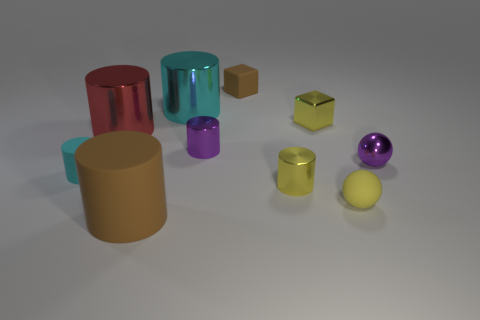What is the material of the thing that is the same color as the small rubber cube?
Keep it short and to the point. Rubber. How many other things are the same material as the yellow cylinder?
Offer a terse response. 5. What is the shape of the cyan thing that is behind the matte cylinder to the left of the large red thing?
Give a very brief answer. Cylinder. What size is the cylinder in front of the yellow sphere?
Give a very brief answer. Large. Is the material of the large red thing the same as the tiny yellow sphere?
Offer a terse response. No. The big brown thing that is the same material as the small yellow ball is what shape?
Offer a very short reply. Cylinder. There is a rubber thing behind the metallic ball; what is its color?
Ensure brevity in your answer.  Brown. There is a matte cylinder that is in front of the cyan rubber thing; is it the same color as the tiny matte block?
Provide a succinct answer. Yes. What material is the yellow object that is the same shape as the cyan metallic object?
Offer a very short reply. Metal. What number of matte blocks are the same size as the shiny sphere?
Give a very brief answer. 1. 